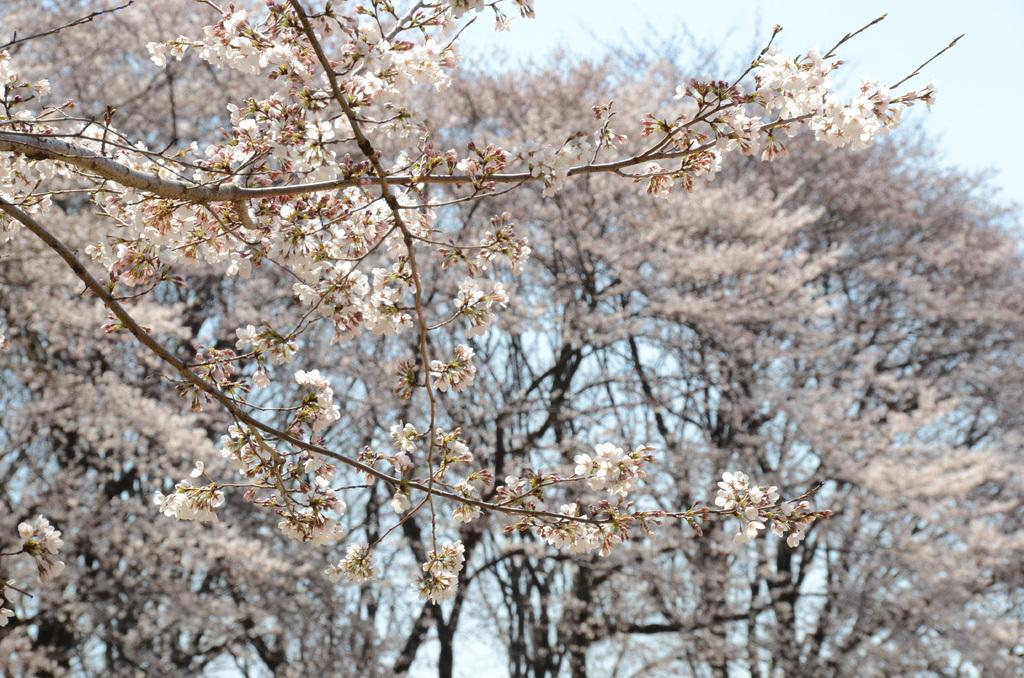How would you summarize this image in a sentence or two? In this image we can see some trees with flowers and dried branches. We can also see the sky which looks cloudy. 